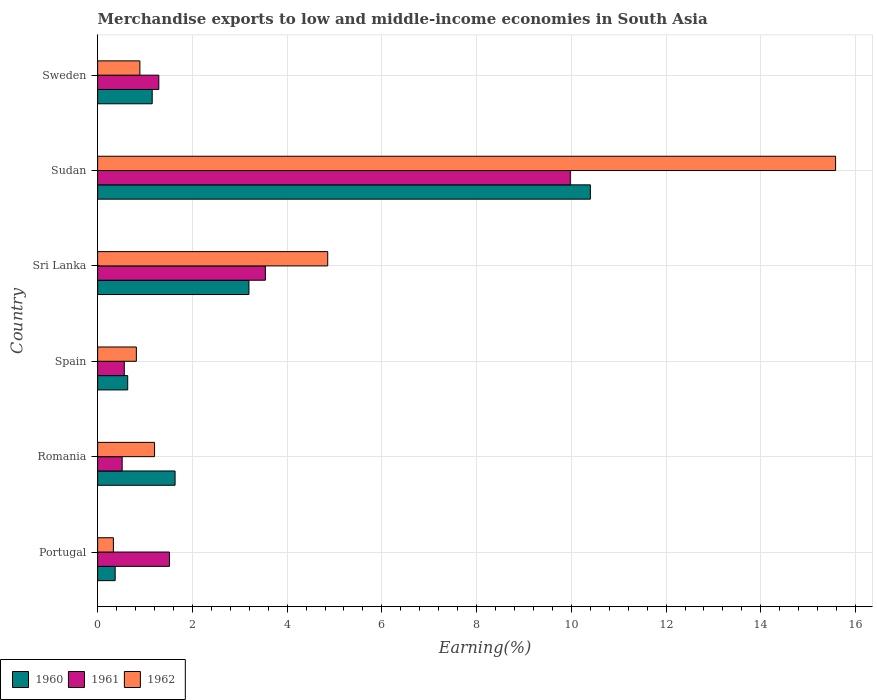How many groups of bars are there?
Keep it short and to the point. 6. Are the number of bars per tick equal to the number of legend labels?
Your answer should be very brief. Yes. How many bars are there on the 3rd tick from the bottom?
Offer a terse response. 3. What is the label of the 3rd group of bars from the top?
Offer a terse response. Sri Lanka. What is the percentage of amount earned from merchandise exports in 1962 in Sudan?
Your answer should be very brief. 15.58. Across all countries, what is the maximum percentage of amount earned from merchandise exports in 1962?
Give a very brief answer. 15.58. Across all countries, what is the minimum percentage of amount earned from merchandise exports in 1961?
Offer a very short reply. 0.52. In which country was the percentage of amount earned from merchandise exports in 1961 maximum?
Give a very brief answer. Sudan. What is the total percentage of amount earned from merchandise exports in 1962 in the graph?
Offer a very short reply. 23.68. What is the difference between the percentage of amount earned from merchandise exports in 1962 in Portugal and that in Sweden?
Make the answer very short. -0.56. What is the difference between the percentage of amount earned from merchandise exports in 1961 in Portugal and the percentage of amount earned from merchandise exports in 1960 in Sweden?
Your response must be concise. 0.36. What is the average percentage of amount earned from merchandise exports in 1960 per country?
Offer a very short reply. 2.9. What is the difference between the percentage of amount earned from merchandise exports in 1960 and percentage of amount earned from merchandise exports in 1962 in Sweden?
Your answer should be compact. 0.26. What is the ratio of the percentage of amount earned from merchandise exports in 1961 in Spain to that in Sweden?
Provide a short and direct response. 0.44. Is the percentage of amount earned from merchandise exports in 1961 in Portugal less than that in Sweden?
Ensure brevity in your answer.  No. What is the difference between the highest and the second highest percentage of amount earned from merchandise exports in 1962?
Offer a very short reply. 10.72. What is the difference between the highest and the lowest percentage of amount earned from merchandise exports in 1962?
Offer a very short reply. 15.25. Is the sum of the percentage of amount earned from merchandise exports in 1962 in Portugal and Romania greater than the maximum percentage of amount earned from merchandise exports in 1961 across all countries?
Offer a very short reply. No. What does the 3rd bar from the bottom in Sudan represents?
Offer a terse response. 1962. Are all the bars in the graph horizontal?
Offer a terse response. Yes. What is the difference between two consecutive major ticks on the X-axis?
Ensure brevity in your answer.  2. Are the values on the major ticks of X-axis written in scientific E-notation?
Your answer should be compact. No. Where does the legend appear in the graph?
Make the answer very short. Bottom left. How many legend labels are there?
Offer a terse response. 3. How are the legend labels stacked?
Ensure brevity in your answer.  Horizontal. What is the title of the graph?
Provide a succinct answer. Merchandise exports to low and middle-income economies in South Asia. What is the label or title of the X-axis?
Keep it short and to the point. Earning(%). What is the label or title of the Y-axis?
Keep it short and to the point. Country. What is the Earning(%) of 1960 in Portugal?
Keep it short and to the point. 0.37. What is the Earning(%) in 1961 in Portugal?
Make the answer very short. 1.52. What is the Earning(%) in 1962 in Portugal?
Keep it short and to the point. 0.33. What is the Earning(%) of 1960 in Romania?
Ensure brevity in your answer.  1.63. What is the Earning(%) of 1961 in Romania?
Ensure brevity in your answer.  0.52. What is the Earning(%) of 1962 in Romania?
Give a very brief answer. 1.2. What is the Earning(%) of 1960 in Spain?
Your answer should be compact. 0.63. What is the Earning(%) of 1961 in Spain?
Offer a terse response. 0.56. What is the Earning(%) in 1962 in Spain?
Provide a succinct answer. 0.82. What is the Earning(%) in 1960 in Sri Lanka?
Your response must be concise. 3.19. What is the Earning(%) of 1961 in Sri Lanka?
Your answer should be compact. 3.54. What is the Earning(%) of 1962 in Sri Lanka?
Keep it short and to the point. 4.86. What is the Earning(%) of 1960 in Sudan?
Make the answer very short. 10.4. What is the Earning(%) of 1961 in Sudan?
Provide a succinct answer. 9.98. What is the Earning(%) in 1962 in Sudan?
Ensure brevity in your answer.  15.58. What is the Earning(%) in 1960 in Sweden?
Provide a succinct answer. 1.15. What is the Earning(%) of 1961 in Sweden?
Your response must be concise. 1.29. What is the Earning(%) in 1962 in Sweden?
Keep it short and to the point. 0.89. Across all countries, what is the maximum Earning(%) in 1960?
Ensure brevity in your answer.  10.4. Across all countries, what is the maximum Earning(%) of 1961?
Give a very brief answer. 9.98. Across all countries, what is the maximum Earning(%) in 1962?
Offer a very short reply. 15.58. Across all countries, what is the minimum Earning(%) in 1960?
Your response must be concise. 0.37. Across all countries, what is the minimum Earning(%) of 1961?
Provide a succinct answer. 0.52. Across all countries, what is the minimum Earning(%) of 1962?
Keep it short and to the point. 0.33. What is the total Earning(%) in 1960 in the graph?
Give a very brief answer. 17.39. What is the total Earning(%) of 1961 in the graph?
Give a very brief answer. 17.41. What is the total Earning(%) of 1962 in the graph?
Provide a short and direct response. 23.68. What is the difference between the Earning(%) of 1960 in Portugal and that in Romania?
Provide a succinct answer. -1.26. What is the difference between the Earning(%) of 1961 in Portugal and that in Romania?
Your answer should be compact. 1. What is the difference between the Earning(%) of 1962 in Portugal and that in Romania?
Ensure brevity in your answer.  -0.87. What is the difference between the Earning(%) of 1960 in Portugal and that in Spain?
Provide a succinct answer. -0.26. What is the difference between the Earning(%) of 1961 in Portugal and that in Spain?
Ensure brevity in your answer.  0.95. What is the difference between the Earning(%) in 1962 in Portugal and that in Spain?
Your response must be concise. -0.48. What is the difference between the Earning(%) in 1960 in Portugal and that in Sri Lanka?
Make the answer very short. -2.82. What is the difference between the Earning(%) of 1961 in Portugal and that in Sri Lanka?
Give a very brief answer. -2.03. What is the difference between the Earning(%) in 1962 in Portugal and that in Sri Lanka?
Provide a succinct answer. -4.52. What is the difference between the Earning(%) in 1960 in Portugal and that in Sudan?
Keep it short and to the point. -10.03. What is the difference between the Earning(%) of 1961 in Portugal and that in Sudan?
Provide a short and direct response. -8.46. What is the difference between the Earning(%) in 1962 in Portugal and that in Sudan?
Make the answer very short. -15.25. What is the difference between the Earning(%) of 1960 in Portugal and that in Sweden?
Your answer should be very brief. -0.78. What is the difference between the Earning(%) of 1961 in Portugal and that in Sweden?
Your response must be concise. 0.22. What is the difference between the Earning(%) of 1962 in Portugal and that in Sweden?
Ensure brevity in your answer.  -0.56. What is the difference between the Earning(%) in 1961 in Romania and that in Spain?
Your response must be concise. -0.05. What is the difference between the Earning(%) of 1962 in Romania and that in Spain?
Make the answer very short. 0.38. What is the difference between the Earning(%) in 1960 in Romania and that in Sri Lanka?
Offer a terse response. -1.56. What is the difference between the Earning(%) of 1961 in Romania and that in Sri Lanka?
Offer a very short reply. -3.02. What is the difference between the Earning(%) in 1962 in Romania and that in Sri Lanka?
Offer a terse response. -3.66. What is the difference between the Earning(%) of 1960 in Romania and that in Sudan?
Make the answer very short. -8.77. What is the difference between the Earning(%) of 1961 in Romania and that in Sudan?
Offer a very short reply. -9.46. What is the difference between the Earning(%) of 1962 in Romania and that in Sudan?
Make the answer very short. -14.38. What is the difference between the Earning(%) of 1960 in Romania and that in Sweden?
Offer a terse response. 0.48. What is the difference between the Earning(%) of 1961 in Romania and that in Sweden?
Your answer should be very brief. -0.77. What is the difference between the Earning(%) in 1962 in Romania and that in Sweden?
Make the answer very short. 0.31. What is the difference between the Earning(%) in 1960 in Spain and that in Sri Lanka?
Give a very brief answer. -2.56. What is the difference between the Earning(%) of 1961 in Spain and that in Sri Lanka?
Keep it short and to the point. -2.98. What is the difference between the Earning(%) of 1962 in Spain and that in Sri Lanka?
Provide a succinct answer. -4.04. What is the difference between the Earning(%) in 1960 in Spain and that in Sudan?
Provide a succinct answer. -9.77. What is the difference between the Earning(%) in 1961 in Spain and that in Sudan?
Provide a short and direct response. -9.41. What is the difference between the Earning(%) in 1962 in Spain and that in Sudan?
Your answer should be very brief. -14.76. What is the difference between the Earning(%) of 1960 in Spain and that in Sweden?
Give a very brief answer. -0.52. What is the difference between the Earning(%) in 1961 in Spain and that in Sweden?
Ensure brevity in your answer.  -0.73. What is the difference between the Earning(%) in 1962 in Spain and that in Sweden?
Keep it short and to the point. -0.07. What is the difference between the Earning(%) in 1960 in Sri Lanka and that in Sudan?
Your answer should be very brief. -7.21. What is the difference between the Earning(%) of 1961 in Sri Lanka and that in Sudan?
Offer a terse response. -6.44. What is the difference between the Earning(%) of 1962 in Sri Lanka and that in Sudan?
Your answer should be very brief. -10.72. What is the difference between the Earning(%) of 1960 in Sri Lanka and that in Sweden?
Your answer should be compact. 2.04. What is the difference between the Earning(%) in 1961 in Sri Lanka and that in Sweden?
Your response must be concise. 2.25. What is the difference between the Earning(%) in 1962 in Sri Lanka and that in Sweden?
Offer a terse response. 3.97. What is the difference between the Earning(%) in 1960 in Sudan and that in Sweden?
Offer a very short reply. 9.25. What is the difference between the Earning(%) of 1961 in Sudan and that in Sweden?
Offer a very short reply. 8.69. What is the difference between the Earning(%) of 1962 in Sudan and that in Sweden?
Make the answer very short. 14.69. What is the difference between the Earning(%) of 1960 in Portugal and the Earning(%) of 1961 in Romania?
Give a very brief answer. -0.15. What is the difference between the Earning(%) of 1960 in Portugal and the Earning(%) of 1962 in Romania?
Your answer should be compact. -0.83. What is the difference between the Earning(%) of 1961 in Portugal and the Earning(%) of 1962 in Romania?
Offer a terse response. 0.31. What is the difference between the Earning(%) in 1960 in Portugal and the Earning(%) in 1961 in Spain?
Provide a short and direct response. -0.19. What is the difference between the Earning(%) of 1960 in Portugal and the Earning(%) of 1962 in Spain?
Ensure brevity in your answer.  -0.45. What is the difference between the Earning(%) of 1961 in Portugal and the Earning(%) of 1962 in Spain?
Your answer should be compact. 0.7. What is the difference between the Earning(%) of 1960 in Portugal and the Earning(%) of 1961 in Sri Lanka?
Provide a succinct answer. -3.17. What is the difference between the Earning(%) of 1960 in Portugal and the Earning(%) of 1962 in Sri Lanka?
Provide a succinct answer. -4.49. What is the difference between the Earning(%) in 1961 in Portugal and the Earning(%) in 1962 in Sri Lanka?
Your response must be concise. -3.34. What is the difference between the Earning(%) of 1960 in Portugal and the Earning(%) of 1961 in Sudan?
Provide a succinct answer. -9.61. What is the difference between the Earning(%) of 1960 in Portugal and the Earning(%) of 1962 in Sudan?
Give a very brief answer. -15.21. What is the difference between the Earning(%) in 1961 in Portugal and the Earning(%) in 1962 in Sudan?
Ensure brevity in your answer.  -14.06. What is the difference between the Earning(%) in 1960 in Portugal and the Earning(%) in 1961 in Sweden?
Provide a short and direct response. -0.92. What is the difference between the Earning(%) of 1960 in Portugal and the Earning(%) of 1962 in Sweden?
Your answer should be compact. -0.52. What is the difference between the Earning(%) in 1961 in Portugal and the Earning(%) in 1962 in Sweden?
Provide a short and direct response. 0.62. What is the difference between the Earning(%) in 1960 in Romania and the Earning(%) in 1961 in Spain?
Your answer should be very brief. 1.07. What is the difference between the Earning(%) of 1960 in Romania and the Earning(%) of 1962 in Spain?
Ensure brevity in your answer.  0.82. What is the difference between the Earning(%) of 1961 in Romania and the Earning(%) of 1962 in Spain?
Offer a very short reply. -0.3. What is the difference between the Earning(%) of 1960 in Romania and the Earning(%) of 1961 in Sri Lanka?
Your answer should be very brief. -1.91. What is the difference between the Earning(%) in 1960 in Romania and the Earning(%) in 1962 in Sri Lanka?
Your answer should be very brief. -3.22. What is the difference between the Earning(%) of 1961 in Romania and the Earning(%) of 1962 in Sri Lanka?
Keep it short and to the point. -4.34. What is the difference between the Earning(%) of 1960 in Romania and the Earning(%) of 1961 in Sudan?
Keep it short and to the point. -8.34. What is the difference between the Earning(%) in 1960 in Romania and the Earning(%) in 1962 in Sudan?
Your answer should be very brief. -13.94. What is the difference between the Earning(%) of 1961 in Romania and the Earning(%) of 1962 in Sudan?
Your answer should be compact. -15.06. What is the difference between the Earning(%) of 1960 in Romania and the Earning(%) of 1961 in Sweden?
Provide a short and direct response. 0.34. What is the difference between the Earning(%) in 1960 in Romania and the Earning(%) in 1962 in Sweden?
Provide a succinct answer. 0.74. What is the difference between the Earning(%) in 1961 in Romania and the Earning(%) in 1962 in Sweden?
Provide a short and direct response. -0.37. What is the difference between the Earning(%) in 1960 in Spain and the Earning(%) in 1961 in Sri Lanka?
Offer a terse response. -2.91. What is the difference between the Earning(%) of 1960 in Spain and the Earning(%) of 1962 in Sri Lanka?
Give a very brief answer. -4.22. What is the difference between the Earning(%) in 1961 in Spain and the Earning(%) in 1962 in Sri Lanka?
Your answer should be very brief. -4.29. What is the difference between the Earning(%) of 1960 in Spain and the Earning(%) of 1961 in Sudan?
Give a very brief answer. -9.34. What is the difference between the Earning(%) of 1960 in Spain and the Earning(%) of 1962 in Sudan?
Ensure brevity in your answer.  -14.94. What is the difference between the Earning(%) of 1961 in Spain and the Earning(%) of 1962 in Sudan?
Provide a succinct answer. -15.02. What is the difference between the Earning(%) of 1960 in Spain and the Earning(%) of 1961 in Sweden?
Make the answer very short. -0.66. What is the difference between the Earning(%) of 1960 in Spain and the Earning(%) of 1962 in Sweden?
Your answer should be very brief. -0.26. What is the difference between the Earning(%) in 1961 in Spain and the Earning(%) in 1962 in Sweden?
Your answer should be compact. -0.33. What is the difference between the Earning(%) in 1960 in Sri Lanka and the Earning(%) in 1961 in Sudan?
Your answer should be compact. -6.78. What is the difference between the Earning(%) in 1960 in Sri Lanka and the Earning(%) in 1962 in Sudan?
Provide a short and direct response. -12.38. What is the difference between the Earning(%) in 1961 in Sri Lanka and the Earning(%) in 1962 in Sudan?
Offer a very short reply. -12.04. What is the difference between the Earning(%) of 1960 in Sri Lanka and the Earning(%) of 1961 in Sweden?
Ensure brevity in your answer.  1.9. What is the difference between the Earning(%) in 1960 in Sri Lanka and the Earning(%) in 1962 in Sweden?
Keep it short and to the point. 2.3. What is the difference between the Earning(%) in 1961 in Sri Lanka and the Earning(%) in 1962 in Sweden?
Provide a succinct answer. 2.65. What is the difference between the Earning(%) of 1960 in Sudan and the Earning(%) of 1961 in Sweden?
Provide a short and direct response. 9.11. What is the difference between the Earning(%) of 1960 in Sudan and the Earning(%) of 1962 in Sweden?
Give a very brief answer. 9.51. What is the difference between the Earning(%) in 1961 in Sudan and the Earning(%) in 1962 in Sweden?
Make the answer very short. 9.09. What is the average Earning(%) of 1960 per country?
Your answer should be compact. 2.9. What is the average Earning(%) of 1961 per country?
Offer a terse response. 2.9. What is the average Earning(%) of 1962 per country?
Ensure brevity in your answer.  3.95. What is the difference between the Earning(%) in 1960 and Earning(%) in 1961 in Portugal?
Offer a very short reply. -1.15. What is the difference between the Earning(%) of 1960 and Earning(%) of 1962 in Portugal?
Give a very brief answer. 0.04. What is the difference between the Earning(%) of 1961 and Earning(%) of 1962 in Portugal?
Make the answer very short. 1.18. What is the difference between the Earning(%) in 1960 and Earning(%) in 1961 in Romania?
Give a very brief answer. 1.12. What is the difference between the Earning(%) in 1960 and Earning(%) in 1962 in Romania?
Give a very brief answer. 0.43. What is the difference between the Earning(%) of 1961 and Earning(%) of 1962 in Romania?
Your answer should be very brief. -0.68. What is the difference between the Earning(%) in 1960 and Earning(%) in 1961 in Spain?
Your response must be concise. 0.07. What is the difference between the Earning(%) in 1960 and Earning(%) in 1962 in Spain?
Your answer should be very brief. -0.18. What is the difference between the Earning(%) in 1961 and Earning(%) in 1962 in Spain?
Offer a terse response. -0.25. What is the difference between the Earning(%) in 1960 and Earning(%) in 1961 in Sri Lanka?
Your response must be concise. -0.35. What is the difference between the Earning(%) of 1960 and Earning(%) of 1962 in Sri Lanka?
Give a very brief answer. -1.66. What is the difference between the Earning(%) in 1961 and Earning(%) in 1962 in Sri Lanka?
Offer a terse response. -1.32. What is the difference between the Earning(%) in 1960 and Earning(%) in 1961 in Sudan?
Provide a short and direct response. 0.42. What is the difference between the Earning(%) of 1960 and Earning(%) of 1962 in Sudan?
Keep it short and to the point. -5.18. What is the difference between the Earning(%) in 1961 and Earning(%) in 1962 in Sudan?
Provide a short and direct response. -5.6. What is the difference between the Earning(%) in 1960 and Earning(%) in 1961 in Sweden?
Your answer should be compact. -0.14. What is the difference between the Earning(%) of 1960 and Earning(%) of 1962 in Sweden?
Ensure brevity in your answer.  0.26. What is the difference between the Earning(%) of 1961 and Earning(%) of 1962 in Sweden?
Offer a very short reply. 0.4. What is the ratio of the Earning(%) in 1960 in Portugal to that in Romania?
Ensure brevity in your answer.  0.23. What is the ratio of the Earning(%) in 1961 in Portugal to that in Romania?
Your response must be concise. 2.93. What is the ratio of the Earning(%) of 1962 in Portugal to that in Romania?
Keep it short and to the point. 0.28. What is the ratio of the Earning(%) in 1960 in Portugal to that in Spain?
Provide a succinct answer. 0.58. What is the ratio of the Earning(%) in 1961 in Portugal to that in Spain?
Your answer should be very brief. 2.69. What is the ratio of the Earning(%) of 1962 in Portugal to that in Spain?
Ensure brevity in your answer.  0.41. What is the ratio of the Earning(%) of 1960 in Portugal to that in Sri Lanka?
Give a very brief answer. 0.12. What is the ratio of the Earning(%) in 1961 in Portugal to that in Sri Lanka?
Offer a very short reply. 0.43. What is the ratio of the Earning(%) of 1962 in Portugal to that in Sri Lanka?
Ensure brevity in your answer.  0.07. What is the ratio of the Earning(%) of 1960 in Portugal to that in Sudan?
Your answer should be very brief. 0.04. What is the ratio of the Earning(%) of 1961 in Portugal to that in Sudan?
Offer a terse response. 0.15. What is the ratio of the Earning(%) in 1962 in Portugal to that in Sudan?
Make the answer very short. 0.02. What is the ratio of the Earning(%) in 1960 in Portugal to that in Sweden?
Provide a short and direct response. 0.32. What is the ratio of the Earning(%) of 1961 in Portugal to that in Sweden?
Provide a succinct answer. 1.17. What is the ratio of the Earning(%) of 1962 in Portugal to that in Sweden?
Offer a very short reply. 0.37. What is the ratio of the Earning(%) of 1960 in Romania to that in Spain?
Offer a terse response. 2.58. What is the ratio of the Earning(%) of 1961 in Romania to that in Spain?
Your response must be concise. 0.92. What is the ratio of the Earning(%) of 1962 in Romania to that in Spain?
Ensure brevity in your answer.  1.47. What is the ratio of the Earning(%) in 1960 in Romania to that in Sri Lanka?
Make the answer very short. 0.51. What is the ratio of the Earning(%) in 1961 in Romania to that in Sri Lanka?
Your answer should be compact. 0.15. What is the ratio of the Earning(%) of 1962 in Romania to that in Sri Lanka?
Provide a succinct answer. 0.25. What is the ratio of the Earning(%) of 1960 in Romania to that in Sudan?
Offer a very short reply. 0.16. What is the ratio of the Earning(%) in 1961 in Romania to that in Sudan?
Ensure brevity in your answer.  0.05. What is the ratio of the Earning(%) of 1962 in Romania to that in Sudan?
Make the answer very short. 0.08. What is the ratio of the Earning(%) of 1960 in Romania to that in Sweden?
Your answer should be compact. 1.42. What is the ratio of the Earning(%) of 1961 in Romania to that in Sweden?
Your answer should be very brief. 0.4. What is the ratio of the Earning(%) in 1962 in Romania to that in Sweden?
Offer a very short reply. 1.35. What is the ratio of the Earning(%) of 1960 in Spain to that in Sri Lanka?
Offer a very short reply. 0.2. What is the ratio of the Earning(%) of 1961 in Spain to that in Sri Lanka?
Your answer should be compact. 0.16. What is the ratio of the Earning(%) in 1962 in Spain to that in Sri Lanka?
Keep it short and to the point. 0.17. What is the ratio of the Earning(%) of 1960 in Spain to that in Sudan?
Offer a very short reply. 0.06. What is the ratio of the Earning(%) of 1961 in Spain to that in Sudan?
Offer a terse response. 0.06. What is the ratio of the Earning(%) of 1962 in Spain to that in Sudan?
Keep it short and to the point. 0.05. What is the ratio of the Earning(%) of 1960 in Spain to that in Sweden?
Ensure brevity in your answer.  0.55. What is the ratio of the Earning(%) in 1961 in Spain to that in Sweden?
Keep it short and to the point. 0.44. What is the ratio of the Earning(%) in 1962 in Spain to that in Sweden?
Your answer should be compact. 0.92. What is the ratio of the Earning(%) in 1960 in Sri Lanka to that in Sudan?
Your response must be concise. 0.31. What is the ratio of the Earning(%) of 1961 in Sri Lanka to that in Sudan?
Offer a terse response. 0.35. What is the ratio of the Earning(%) of 1962 in Sri Lanka to that in Sudan?
Provide a short and direct response. 0.31. What is the ratio of the Earning(%) in 1960 in Sri Lanka to that in Sweden?
Provide a succinct answer. 2.77. What is the ratio of the Earning(%) in 1961 in Sri Lanka to that in Sweden?
Make the answer very short. 2.74. What is the ratio of the Earning(%) of 1962 in Sri Lanka to that in Sweden?
Offer a very short reply. 5.45. What is the ratio of the Earning(%) of 1960 in Sudan to that in Sweden?
Your answer should be compact. 9.03. What is the ratio of the Earning(%) in 1961 in Sudan to that in Sweden?
Make the answer very short. 7.73. What is the ratio of the Earning(%) in 1962 in Sudan to that in Sweden?
Give a very brief answer. 17.47. What is the difference between the highest and the second highest Earning(%) in 1960?
Keep it short and to the point. 7.21. What is the difference between the highest and the second highest Earning(%) of 1961?
Your response must be concise. 6.44. What is the difference between the highest and the second highest Earning(%) in 1962?
Your answer should be very brief. 10.72. What is the difference between the highest and the lowest Earning(%) of 1960?
Your response must be concise. 10.03. What is the difference between the highest and the lowest Earning(%) in 1961?
Offer a terse response. 9.46. What is the difference between the highest and the lowest Earning(%) in 1962?
Make the answer very short. 15.25. 